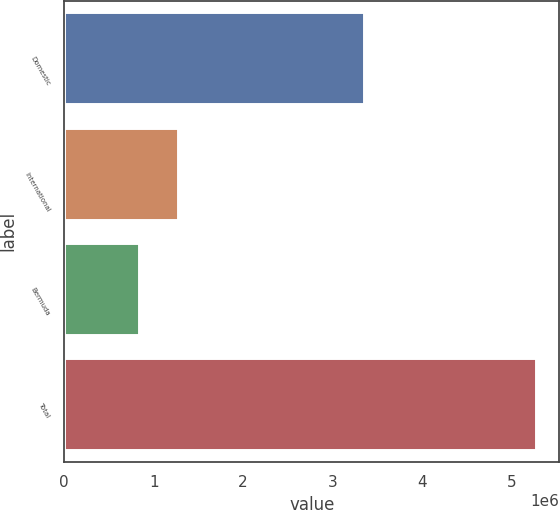Convert chart to OTSL. <chart><loc_0><loc_0><loc_500><loc_500><bar_chart><fcel>Domestic<fcel>International<fcel>Bermuda<fcel>Total<nl><fcel>3.35626e+06<fcel>1.27583e+06<fcel>831931<fcel>5.2709e+06<nl></chart> 